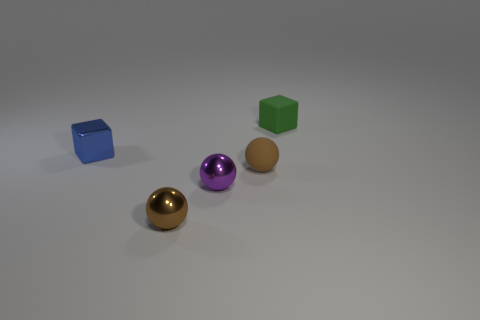Is there another small thing of the same shape as the small green matte object?
Your answer should be compact. Yes. There is a thing that is right of the small purple metal thing and on the left side of the green rubber block; what shape is it?
Your answer should be very brief. Sphere. Do the purple ball and the tiny thing that is in front of the purple ball have the same material?
Keep it short and to the point. Yes. There is a brown metal object; are there any purple spheres right of it?
Provide a short and direct response. Yes. How many things are matte objects or small cubes that are on the left side of the tiny brown rubber object?
Ensure brevity in your answer.  3. There is a small block that is to the left of the brown ball behind the purple sphere; what is its color?
Your answer should be compact. Blue. How many other objects are the same material as the blue block?
Give a very brief answer. 2. What number of shiny objects are either tiny cylinders or small spheres?
Provide a succinct answer. 2. There is another small matte thing that is the same shape as the tiny blue object; what is its color?
Your response must be concise. Green. What number of things are green things or small blue cubes?
Your answer should be compact. 2. 